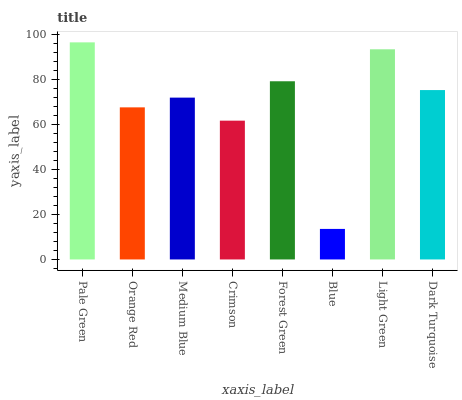Is Blue the minimum?
Answer yes or no. Yes. Is Pale Green the maximum?
Answer yes or no. Yes. Is Orange Red the minimum?
Answer yes or no. No. Is Orange Red the maximum?
Answer yes or no. No. Is Pale Green greater than Orange Red?
Answer yes or no. Yes. Is Orange Red less than Pale Green?
Answer yes or no. Yes. Is Orange Red greater than Pale Green?
Answer yes or no. No. Is Pale Green less than Orange Red?
Answer yes or no. No. Is Dark Turquoise the high median?
Answer yes or no. Yes. Is Medium Blue the low median?
Answer yes or no. Yes. Is Pale Green the high median?
Answer yes or no. No. Is Forest Green the low median?
Answer yes or no. No. 